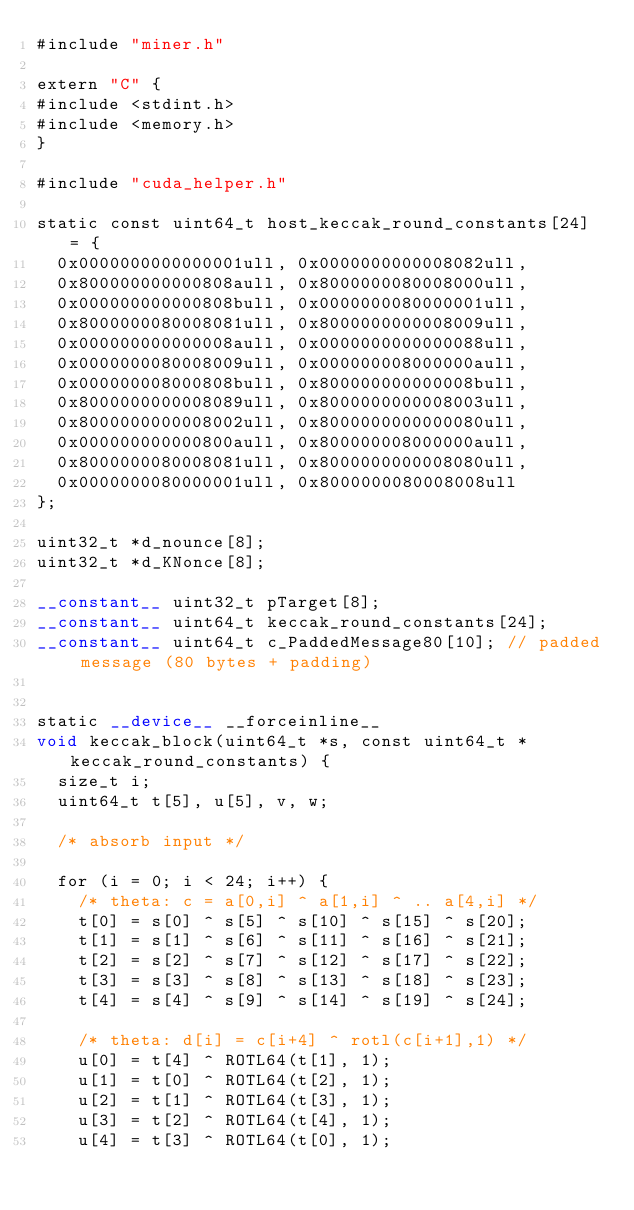Convert code to text. <code><loc_0><loc_0><loc_500><loc_500><_Cuda_>#include "miner.h"

extern "C" {
#include <stdint.h>
#include <memory.h>
}

#include "cuda_helper.h"

static const uint64_t host_keccak_round_constants[24] = {
	0x0000000000000001ull, 0x0000000000008082ull,
	0x800000000000808aull, 0x8000000080008000ull,
	0x000000000000808bull, 0x0000000080000001ull,
	0x8000000080008081ull, 0x8000000000008009ull,
	0x000000000000008aull, 0x0000000000000088ull,
	0x0000000080008009ull, 0x000000008000000aull,
	0x000000008000808bull, 0x800000000000008bull,
	0x8000000000008089ull, 0x8000000000008003ull,
	0x8000000000008002ull, 0x8000000000000080ull,
	0x000000000000800aull, 0x800000008000000aull,
	0x8000000080008081ull, 0x8000000000008080ull,
	0x0000000080000001ull, 0x8000000080008008ull
};

uint32_t *d_nounce[8];
uint32_t *d_KNonce[8];

__constant__ uint32_t pTarget[8];
__constant__ uint64_t keccak_round_constants[24];
__constant__ uint64_t c_PaddedMessage80[10]; // padded message (80 bytes + padding)


static __device__ __forceinline__
void keccak_block(uint64_t *s, const uint64_t *keccak_round_constants) {
	size_t i;
	uint64_t t[5], u[5], v, w;

	/* absorb input */

	for (i = 0; i < 24; i++) {
		/* theta: c = a[0,i] ^ a[1,i] ^ .. a[4,i] */
		t[0] = s[0] ^ s[5] ^ s[10] ^ s[15] ^ s[20];
		t[1] = s[1] ^ s[6] ^ s[11] ^ s[16] ^ s[21];
		t[2] = s[2] ^ s[7] ^ s[12] ^ s[17] ^ s[22];
		t[3] = s[3] ^ s[8] ^ s[13] ^ s[18] ^ s[23];
		t[4] = s[4] ^ s[9] ^ s[14] ^ s[19] ^ s[24];

		/* theta: d[i] = c[i+4] ^ rotl(c[i+1],1) */
		u[0] = t[4] ^ ROTL64(t[1], 1);
		u[1] = t[0] ^ ROTL64(t[2], 1);
		u[2] = t[1] ^ ROTL64(t[3], 1);
		u[3] = t[2] ^ ROTL64(t[4], 1);
		u[4] = t[3] ^ ROTL64(t[0], 1);
</code> 